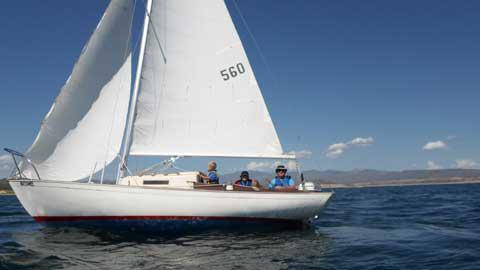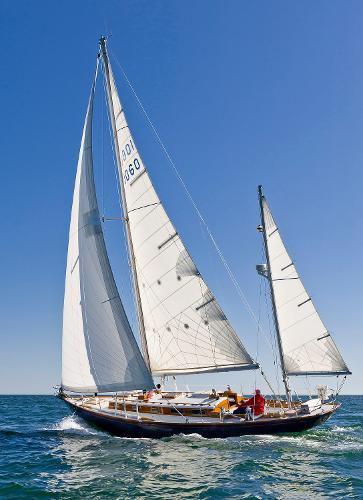The first image is the image on the left, the second image is the image on the right. Evaluate the accuracy of this statement regarding the images: "The sky in the image on the right is cloudless.". Is it true? Answer yes or no. Yes. 